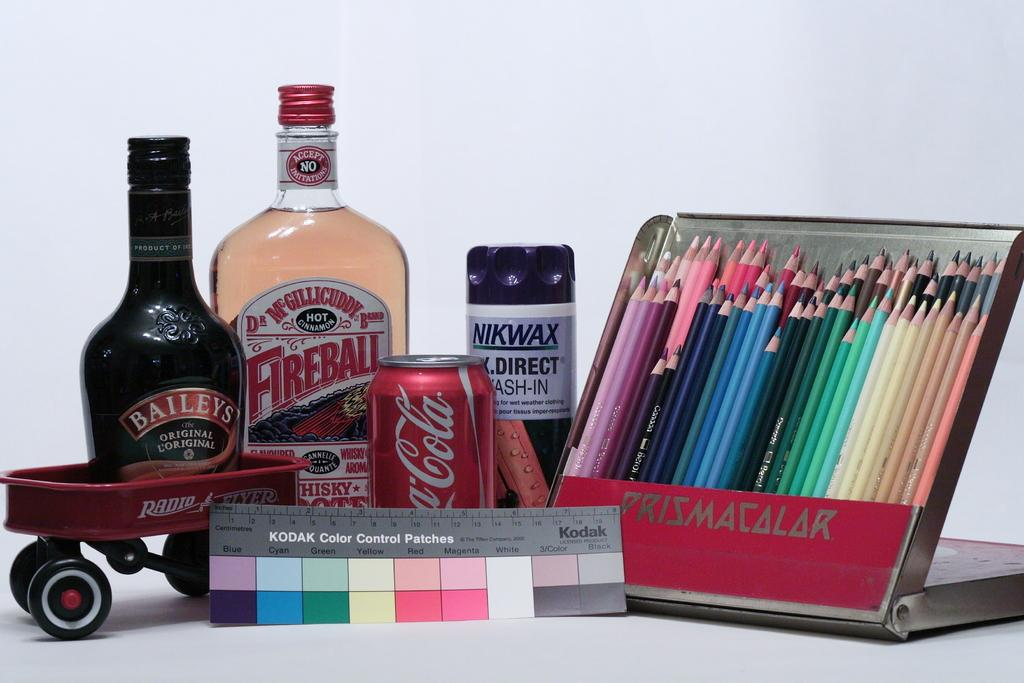<image>
Describe the image concisely. A bottle of baileys and a bottle of fireball with some colored pencils. 